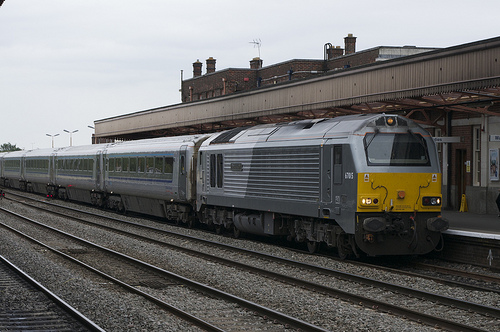Please provide the bounding box coordinate of the region this sentence describes: yellow and red train. The bounding box for the yellow and red train, covering most of its visible area, is approximately at [0.61, 0.38, 0.94, 0.67]. This includes most of the train's body excluding parts that blend into the background. 